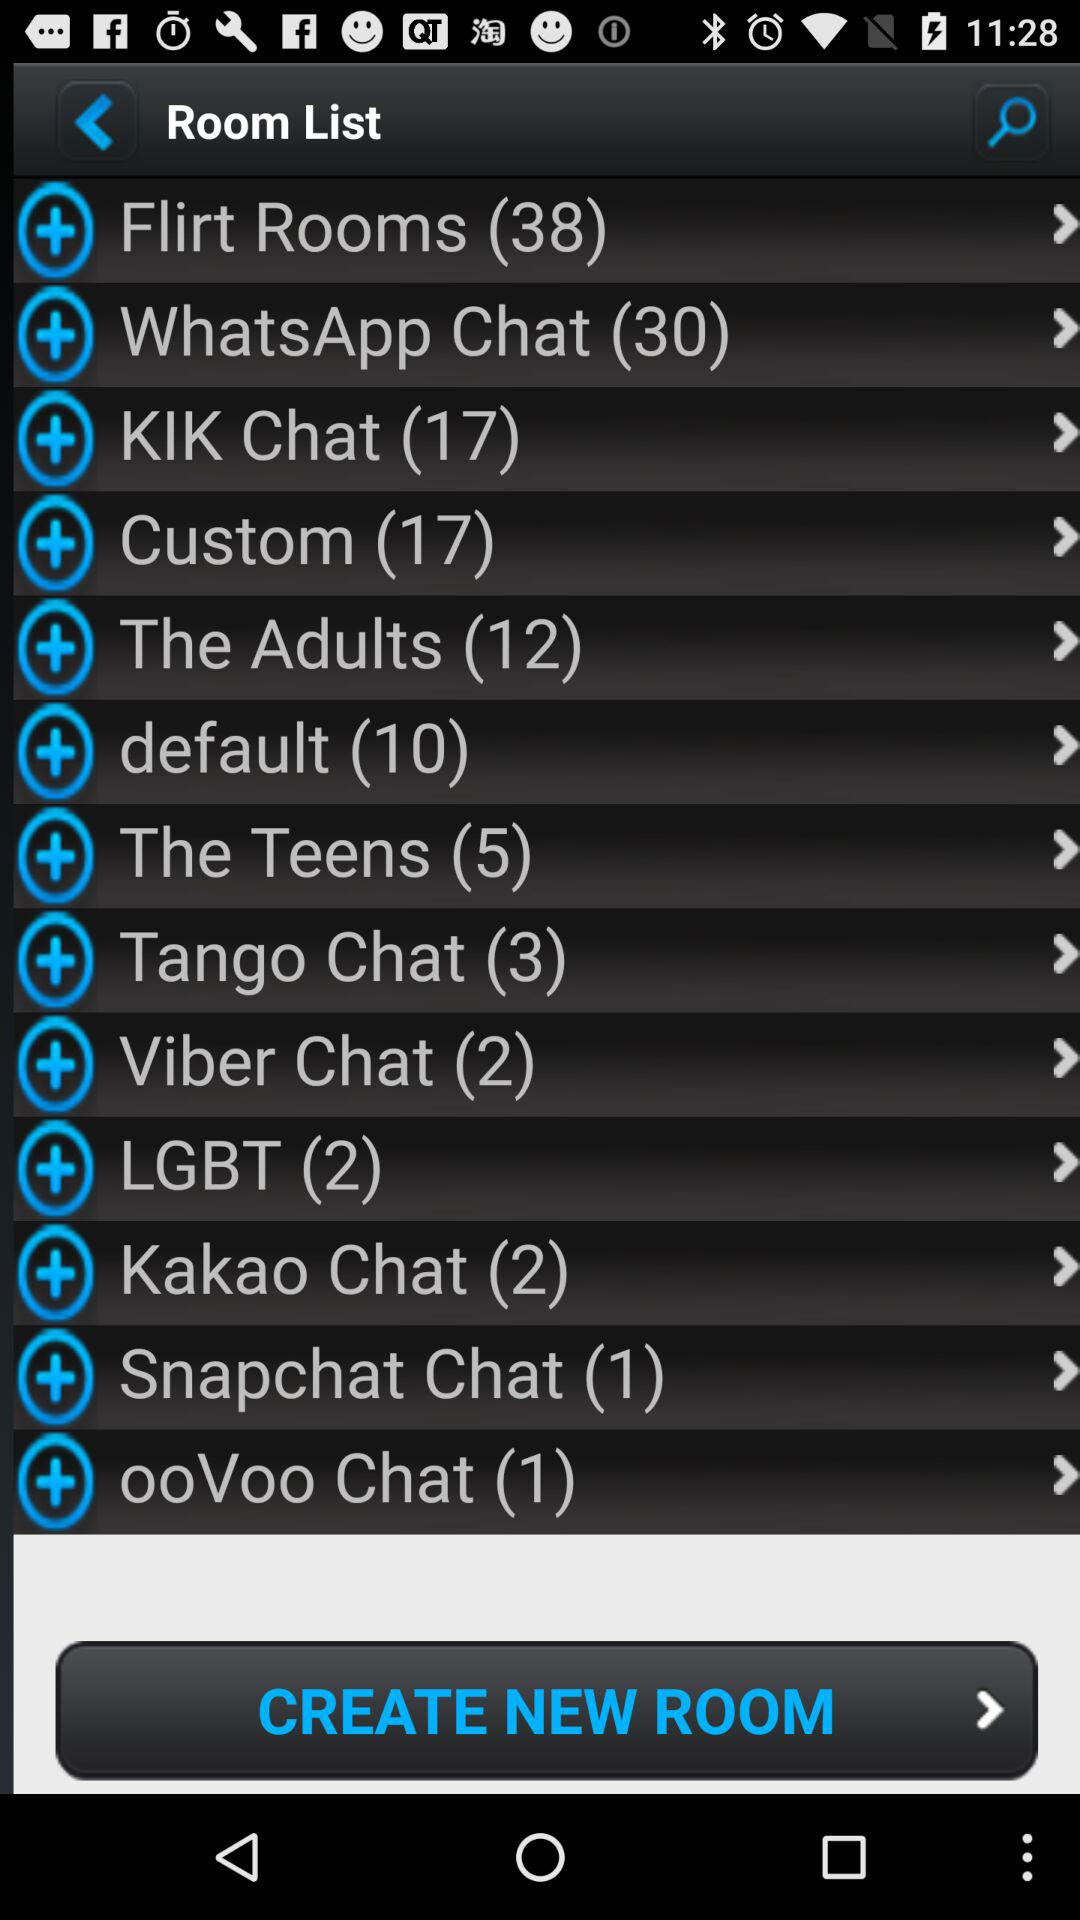What is the number in the Kik chat? The number in the Kik chat is 17. 